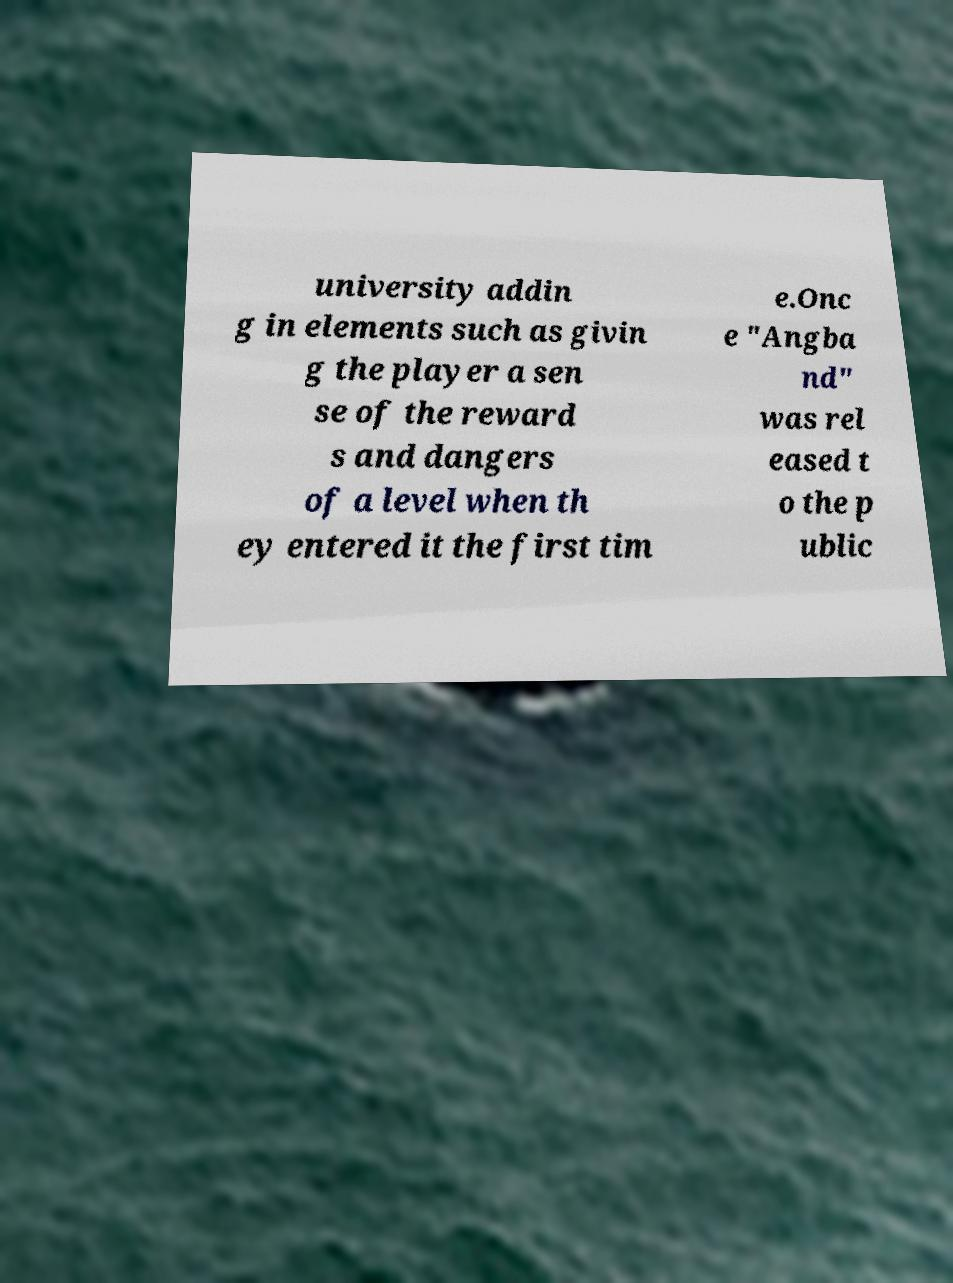I need the written content from this picture converted into text. Can you do that? university addin g in elements such as givin g the player a sen se of the reward s and dangers of a level when th ey entered it the first tim e.Onc e "Angba nd" was rel eased t o the p ublic 